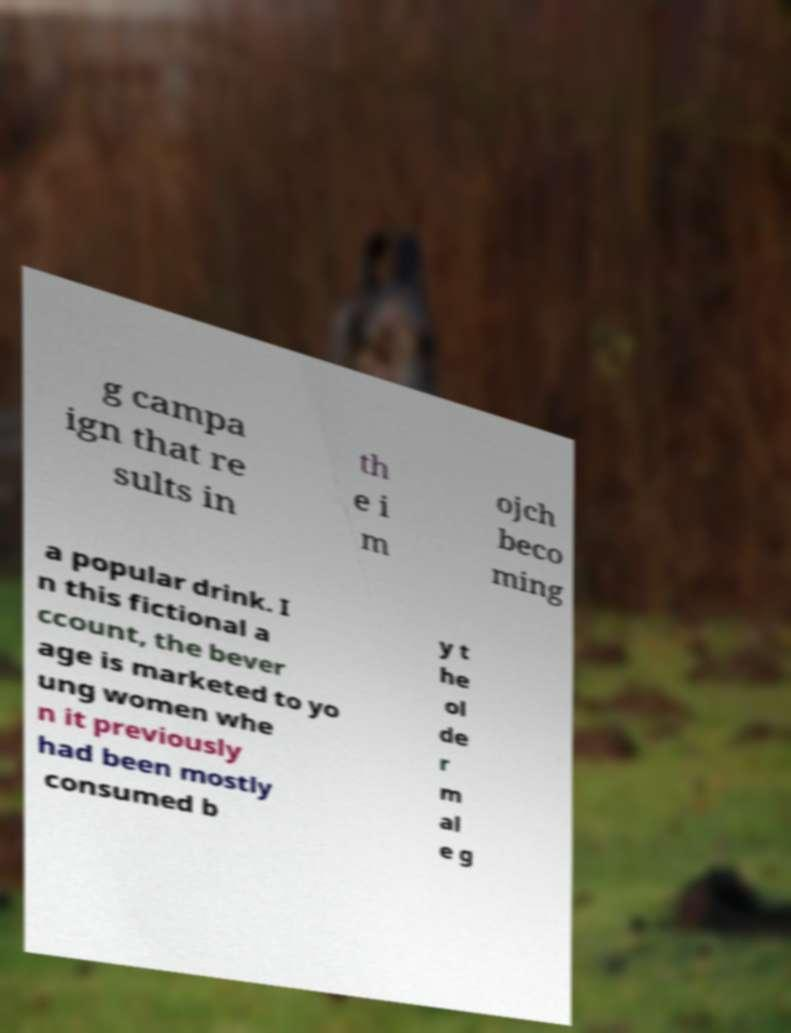Please identify and transcribe the text found in this image. g campa ign that re sults in th e i m ojch beco ming a popular drink. I n this fictional a ccount, the bever age is marketed to yo ung women whe n it previously had been mostly consumed b y t he ol de r m al e g 